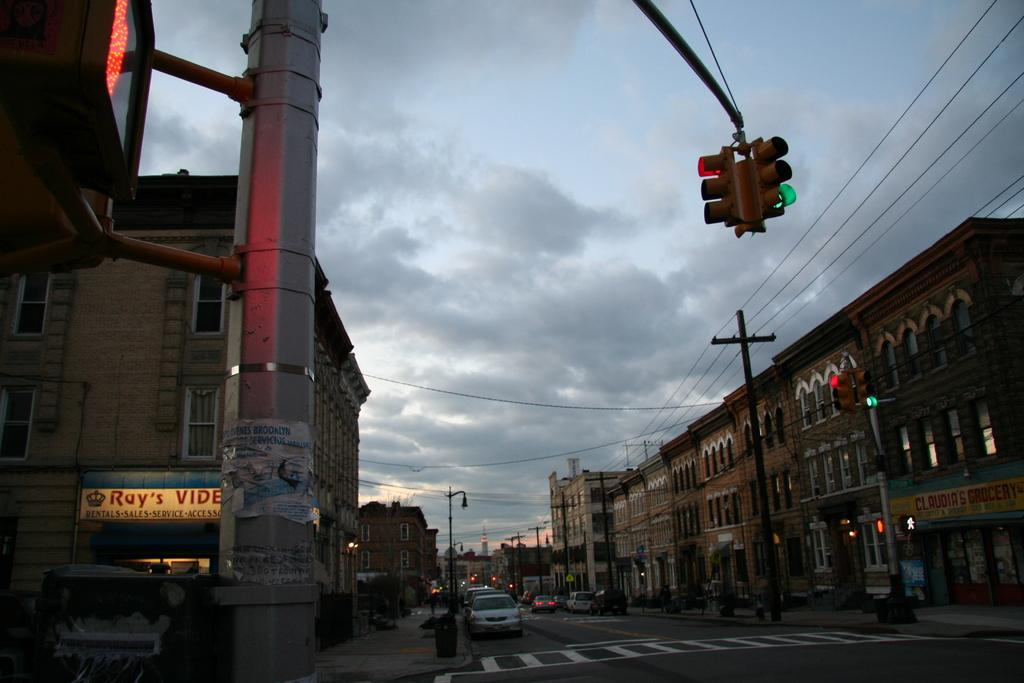<image>
Describe the image concisely. A downtown scene displaying Roy's video store at night. 